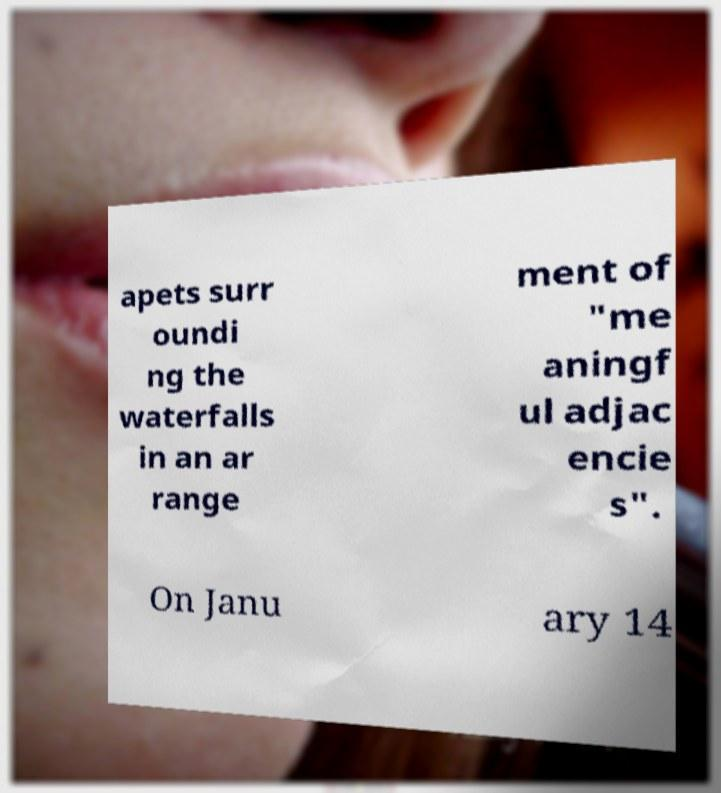What messages or text are displayed in this image? I need them in a readable, typed format. apets surr oundi ng the waterfalls in an ar range ment of "me aningf ul adjac encie s". On Janu ary 14 